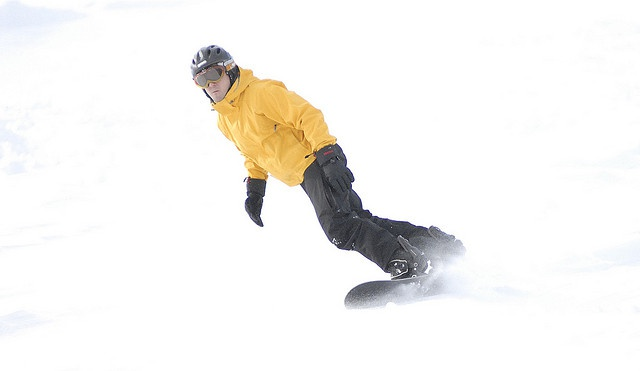Describe the objects in this image and their specific colors. I can see people in white, gray, orange, and gold tones and snowboard in white, lightgray, darkgray, and gray tones in this image. 